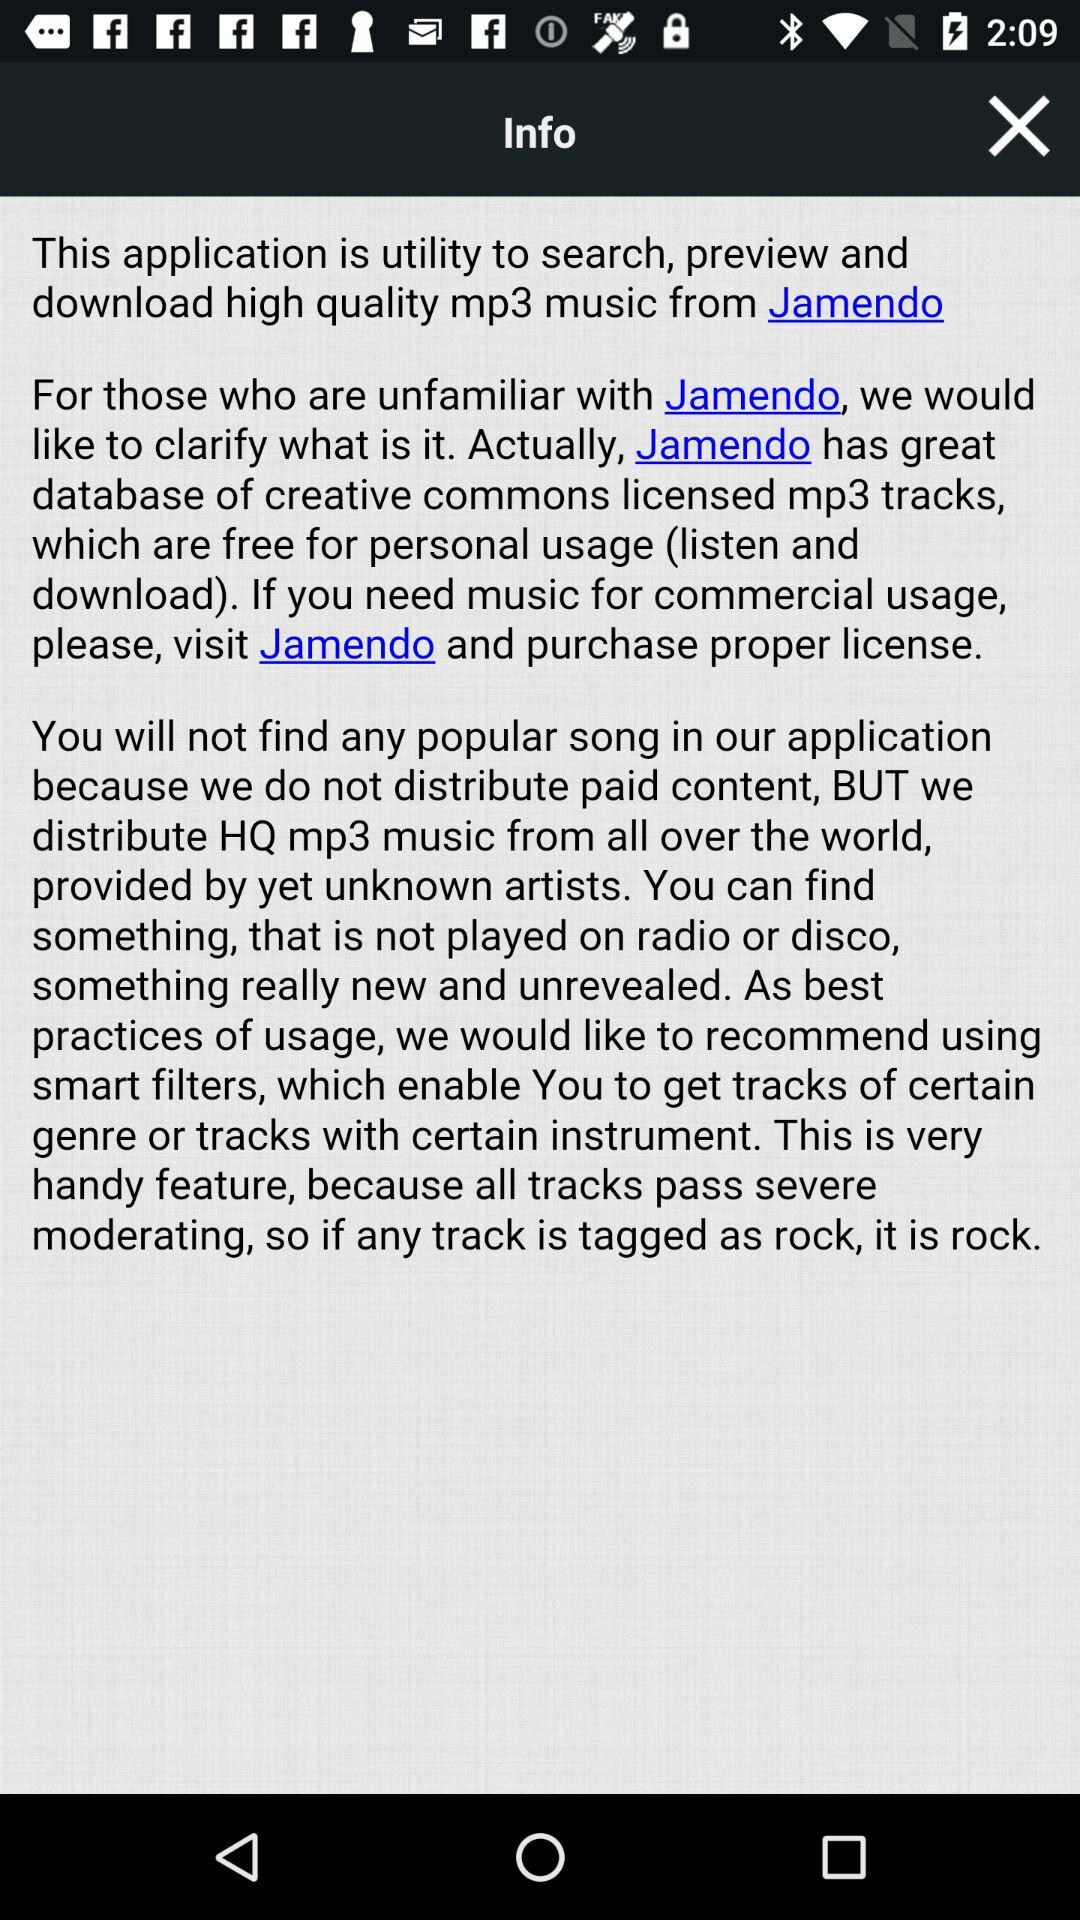What is the name of the application? The name of the application is "Jamendo". 